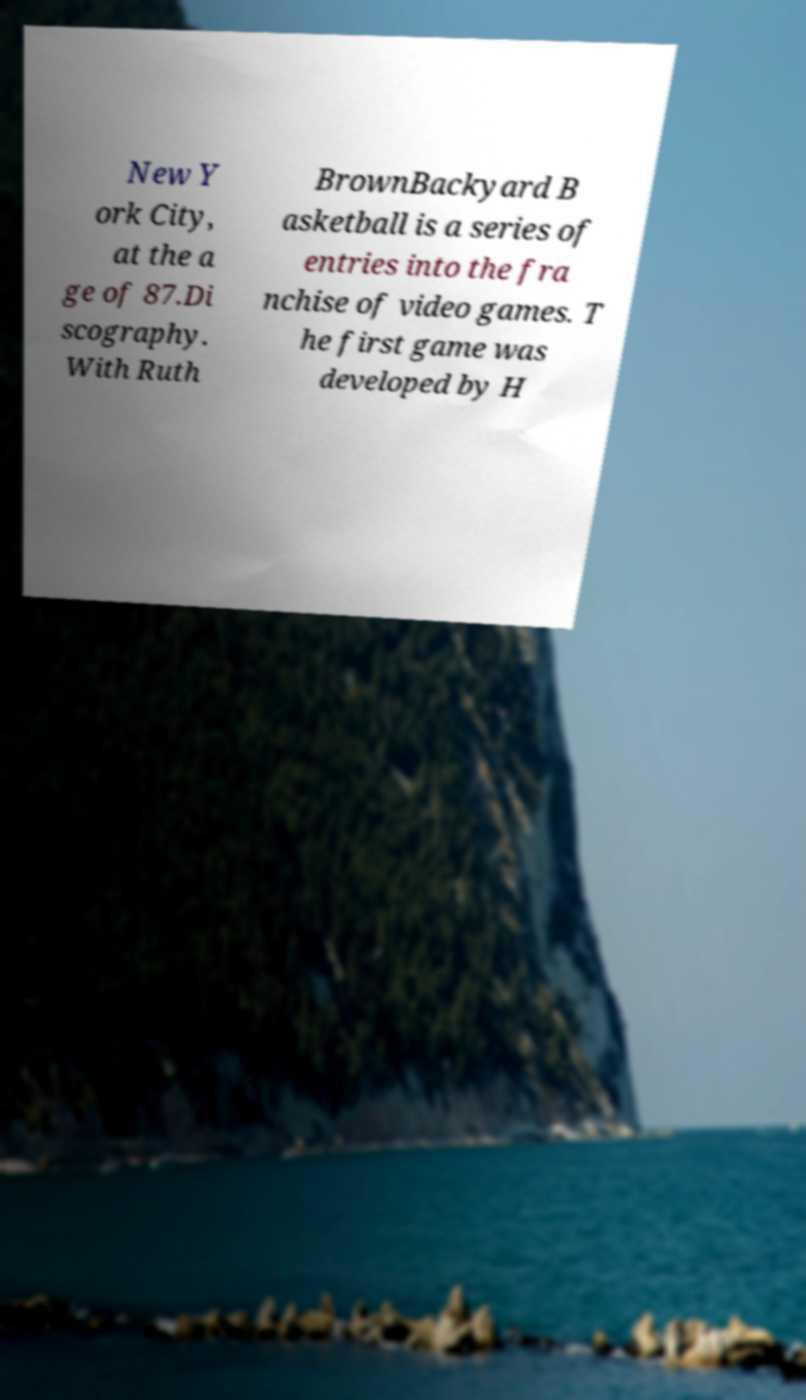Can you accurately transcribe the text from the provided image for me? New Y ork City, at the a ge of 87.Di scography. With Ruth BrownBackyard B asketball is a series of entries into the fra nchise of video games. T he first game was developed by H 